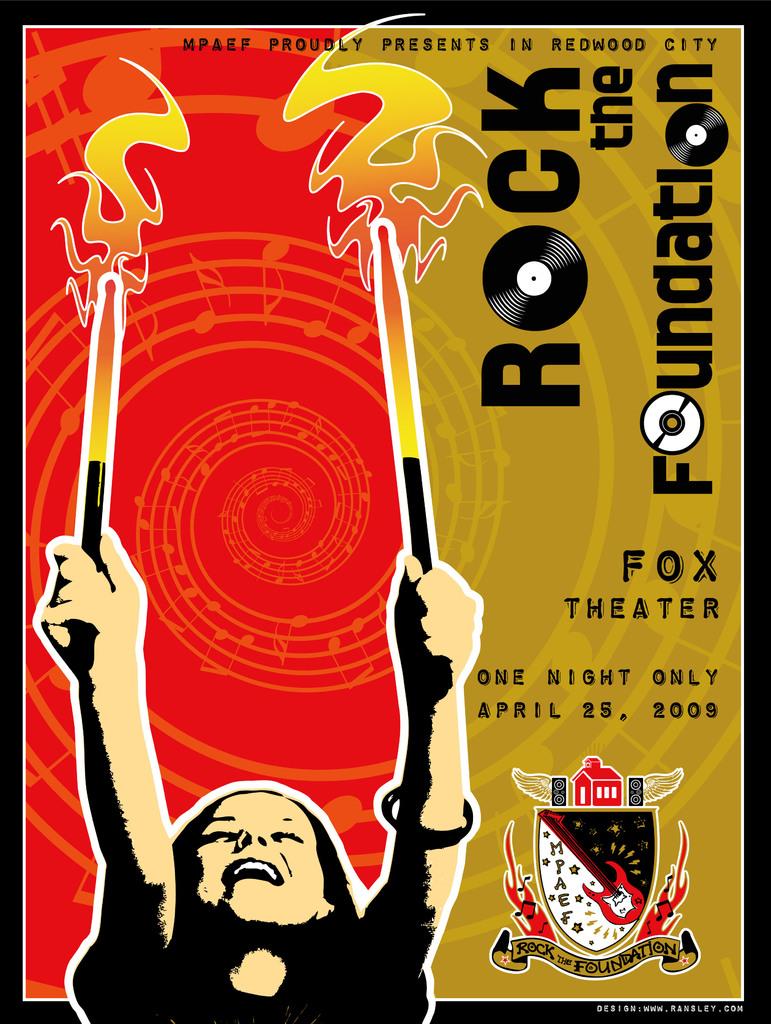Which theater is this event being held?
Offer a terse response. Fox. What is the name of this event?
Make the answer very short. Rock the foundation. 